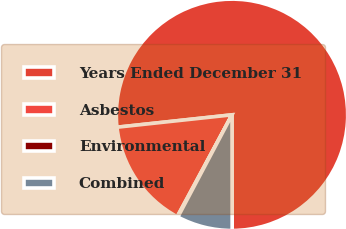Convert chart to OTSL. <chart><loc_0><loc_0><loc_500><loc_500><pie_chart><fcel>Years Ended December 31<fcel>Asbestos<fcel>Environmental<fcel>Combined<nl><fcel>76.69%<fcel>15.43%<fcel>0.11%<fcel>7.77%<nl></chart> 